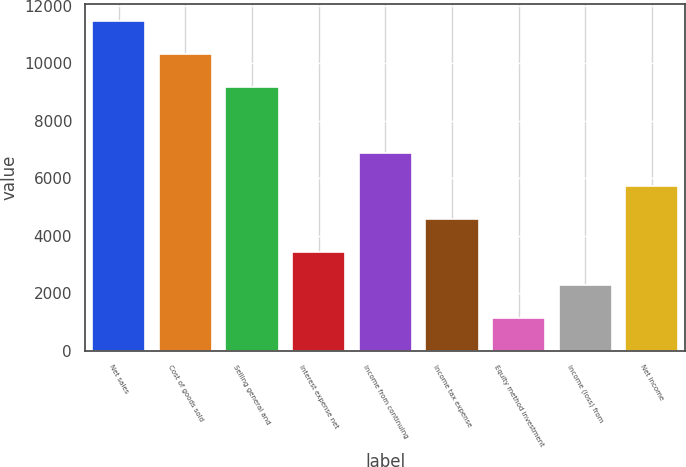Convert chart to OTSL. <chart><loc_0><loc_0><loc_500><loc_500><bar_chart><fcel>Net sales<fcel>Cost of goods sold<fcel>Selling general and<fcel>Interest expense net<fcel>Income from continuing<fcel>Income tax expense<fcel>Equity method investment<fcel>Income (loss) from<fcel>Net income<nl><fcel>11482<fcel>10333.8<fcel>9185.63<fcel>3444.68<fcel>6889.25<fcel>4592.87<fcel>1148.3<fcel>2296.49<fcel>5741.06<nl></chart> 